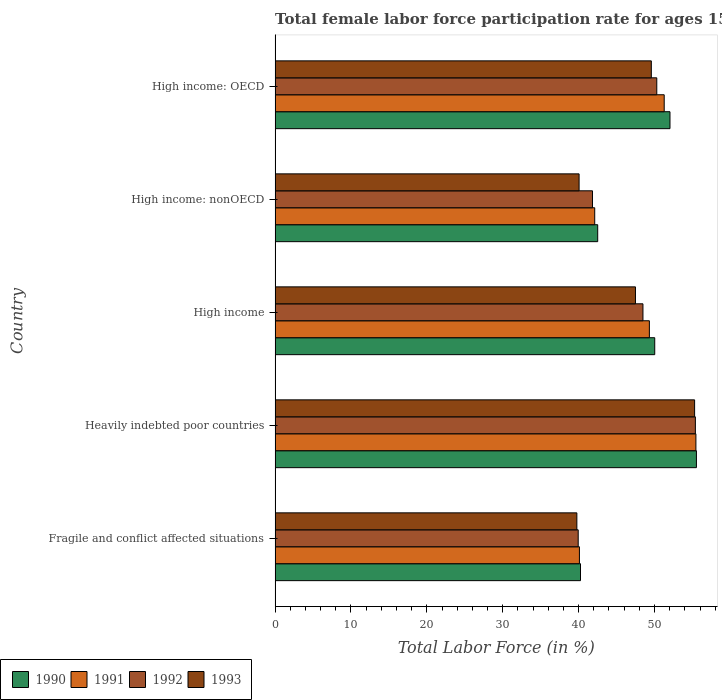How many different coloured bars are there?
Give a very brief answer. 4. Are the number of bars per tick equal to the number of legend labels?
Offer a terse response. Yes. How many bars are there on the 2nd tick from the top?
Your response must be concise. 4. What is the label of the 2nd group of bars from the top?
Provide a succinct answer. High income: nonOECD. What is the female labor force participation rate in 1991 in Fragile and conflict affected situations?
Your answer should be very brief. 40.11. Across all countries, what is the maximum female labor force participation rate in 1992?
Provide a succinct answer. 55.39. Across all countries, what is the minimum female labor force participation rate in 1993?
Provide a succinct answer. 39.77. In which country was the female labor force participation rate in 1993 maximum?
Provide a succinct answer. Heavily indebted poor countries. In which country was the female labor force participation rate in 1993 minimum?
Offer a very short reply. Fragile and conflict affected situations. What is the total female labor force participation rate in 1990 in the graph?
Make the answer very short. 240.38. What is the difference between the female labor force participation rate in 1991 in Heavily indebted poor countries and that in High income: OECD?
Your answer should be very brief. 4.18. What is the difference between the female labor force participation rate in 1990 in High income: OECD and the female labor force participation rate in 1993 in High income: nonOECD?
Your response must be concise. 11.98. What is the average female labor force participation rate in 1993 per country?
Make the answer very short. 46.44. What is the difference between the female labor force participation rate in 1990 and female labor force participation rate in 1993 in Fragile and conflict affected situations?
Your answer should be very brief. 0.48. In how many countries, is the female labor force participation rate in 1990 greater than 34 %?
Provide a succinct answer. 5. What is the ratio of the female labor force participation rate in 1993 in High income to that in High income: nonOECD?
Give a very brief answer. 1.19. Is the female labor force participation rate in 1993 in Heavily indebted poor countries less than that in High income: OECD?
Your response must be concise. No. Is the difference between the female labor force participation rate in 1990 in Heavily indebted poor countries and High income: OECD greater than the difference between the female labor force participation rate in 1993 in Heavily indebted poor countries and High income: OECD?
Your answer should be very brief. No. What is the difference between the highest and the second highest female labor force participation rate in 1992?
Your response must be concise. 5.09. What is the difference between the highest and the lowest female labor force participation rate in 1990?
Your answer should be compact. 15.28. What does the 2nd bar from the bottom in Fragile and conflict affected situations represents?
Ensure brevity in your answer.  1991. Are all the bars in the graph horizontal?
Ensure brevity in your answer.  Yes. What is the difference between two consecutive major ticks on the X-axis?
Make the answer very short. 10. Are the values on the major ticks of X-axis written in scientific E-notation?
Your response must be concise. No. Does the graph contain grids?
Keep it short and to the point. No. How many legend labels are there?
Keep it short and to the point. 4. What is the title of the graph?
Offer a terse response. Total female labor force participation rate for ages 15-24. What is the label or title of the X-axis?
Offer a very short reply. Total Labor Force (in %). What is the Total Labor Force (in %) in 1990 in Fragile and conflict affected situations?
Ensure brevity in your answer.  40.25. What is the Total Labor Force (in %) of 1991 in Fragile and conflict affected situations?
Offer a terse response. 40.11. What is the Total Labor Force (in %) in 1992 in Fragile and conflict affected situations?
Offer a terse response. 39.95. What is the Total Labor Force (in %) in 1993 in Fragile and conflict affected situations?
Make the answer very short. 39.77. What is the Total Labor Force (in %) in 1990 in Heavily indebted poor countries?
Provide a short and direct response. 55.53. What is the Total Labor Force (in %) of 1991 in Heavily indebted poor countries?
Give a very brief answer. 55.46. What is the Total Labor Force (in %) of 1992 in Heavily indebted poor countries?
Your response must be concise. 55.39. What is the Total Labor Force (in %) in 1993 in Heavily indebted poor countries?
Give a very brief answer. 55.29. What is the Total Labor Force (in %) in 1990 in High income?
Offer a terse response. 50.03. What is the Total Labor Force (in %) in 1991 in High income?
Provide a short and direct response. 49.33. What is the Total Labor Force (in %) in 1992 in High income?
Keep it short and to the point. 48.48. What is the Total Labor Force (in %) of 1993 in High income?
Your response must be concise. 47.5. What is the Total Labor Force (in %) of 1990 in High income: nonOECD?
Ensure brevity in your answer.  42.52. What is the Total Labor Force (in %) of 1991 in High income: nonOECD?
Provide a short and direct response. 42.12. What is the Total Labor Force (in %) of 1992 in High income: nonOECD?
Make the answer very short. 41.83. What is the Total Labor Force (in %) of 1993 in High income: nonOECD?
Give a very brief answer. 40.07. What is the Total Labor Force (in %) in 1990 in High income: OECD?
Your response must be concise. 52.04. What is the Total Labor Force (in %) in 1991 in High income: OECD?
Offer a terse response. 51.28. What is the Total Labor Force (in %) of 1992 in High income: OECD?
Your answer should be very brief. 50.3. What is the Total Labor Force (in %) in 1993 in High income: OECD?
Provide a succinct answer. 49.59. Across all countries, what is the maximum Total Labor Force (in %) in 1990?
Offer a terse response. 55.53. Across all countries, what is the maximum Total Labor Force (in %) in 1991?
Give a very brief answer. 55.46. Across all countries, what is the maximum Total Labor Force (in %) in 1992?
Keep it short and to the point. 55.39. Across all countries, what is the maximum Total Labor Force (in %) in 1993?
Give a very brief answer. 55.29. Across all countries, what is the minimum Total Labor Force (in %) of 1990?
Provide a succinct answer. 40.25. Across all countries, what is the minimum Total Labor Force (in %) in 1991?
Ensure brevity in your answer.  40.11. Across all countries, what is the minimum Total Labor Force (in %) in 1992?
Your answer should be compact. 39.95. Across all countries, what is the minimum Total Labor Force (in %) in 1993?
Provide a succinct answer. 39.77. What is the total Total Labor Force (in %) in 1990 in the graph?
Offer a terse response. 240.38. What is the total Total Labor Force (in %) of 1991 in the graph?
Provide a short and direct response. 238.31. What is the total Total Labor Force (in %) of 1992 in the graph?
Give a very brief answer. 235.96. What is the total Total Labor Force (in %) in 1993 in the graph?
Give a very brief answer. 232.21. What is the difference between the Total Labor Force (in %) of 1990 in Fragile and conflict affected situations and that in Heavily indebted poor countries?
Provide a succinct answer. -15.28. What is the difference between the Total Labor Force (in %) of 1991 in Fragile and conflict affected situations and that in Heavily indebted poor countries?
Provide a succinct answer. -15.35. What is the difference between the Total Labor Force (in %) of 1992 in Fragile and conflict affected situations and that in Heavily indebted poor countries?
Provide a succinct answer. -15.44. What is the difference between the Total Labor Force (in %) of 1993 in Fragile and conflict affected situations and that in Heavily indebted poor countries?
Your response must be concise. -15.52. What is the difference between the Total Labor Force (in %) in 1990 in Fragile and conflict affected situations and that in High income?
Provide a short and direct response. -9.78. What is the difference between the Total Labor Force (in %) of 1991 in Fragile and conflict affected situations and that in High income?
Ensure brevity in your answer.  -9.22. What is the difference between the Total Labor Force (in %) of 1992 in Fragile and conflict affected situations and that in High income?
Make the answer very short. -8.53. What is the difference between the Total Labor Force (in %) in 1993 in Fragile and conflict affected situations and that in High income?
Your answer should be very brief. -7.72. What is the difference between the Total Labor Force (in %) in 1990 in Fragile and conflict affected situations and that in High income: nonOECD?
Make the answer very short. -2.27. What is the difference between the Total Labor Force (in %) of 1991 in Fragile and conflict affected situations and that in High income: nonOECD?
Your answer should be very brief. -2.01. What is the difference between the Total Labor Force (in %) in 1992 in Fragile and conflict affected situations and that in High income: nonOECD?
Provide a succinct answer. -1.88. What is the difference between the Total Labor Force (in %) in 1993 in Fragile and conflict affected situations and that in High income: nonOECD?
Offer a terse response. -0.29. What is the difference between the Total Labor Force (in %) in 1990 in Fragile and conflict affected situations and that in High income: OECD?
Your answer should be very brief. -11.79. What is the difference between the Total Labor Force (in %) in 1991 in Fragile and conflict affected situations and that in High income: OECD?
Provide a succinct answer. -11.17. What is the difference between the Total Labor Force (in %) in 1992 in Fragile and conflict affected situations and that in High income: OECD?
Keep it short and to the point. -10.36. What is the difference between the Total Labor Force (in %) in 1993 in Fragile and conflict affected situations and that in High income: OECD?
Offer a very short reply. -9.81. What is the difference between the Total Labor Force (in %) of 1990 in Heavily indebted poor countries and that in High income?
Give a very brief answer. 5.5. What is the difference between the Total Labor Force (in %) in 1991 in Heavily indebted poor countries and that in High income?
Ensure brevity in your answer.  6.13. What is the difference between the Total Labor Force (in %) in 1992 in Heavily indebted poor countries and that in High income?
Your response must be concise. 6.91. What is the difference between the Total Labor Force (in %) of 1993 in Heavily indebted poor countries and that in High income?
Your response must be concise. 7.79. What is the difference between the Total Labor Force (in %) of 1990 in Heavily indebted poor countries and that in High income: nonOECD?
Ensure brevity in your answer.  13.01. What is the difference between the Total Labor Force (in %) in 1991 in Heavily indebted poor countries and that in High income: nonOECD?
Provide a succinct answer. 13.34. What is the difference between the Total Labor Force (in %) of 1992 in Heavily indebted poor countries and that in High income: nonOECD?
Give a very brief answer. 13.56. What is the difference between the Total Labor Force (in %) of 1993 in Heavily indebted poor countries and that in High income: nonOECD?
Provide a short and direct response. 15.22. What is the difference between the Total Labor Force (in %) of 1990 in Heavily indebted poor countries and that in High income: OECD?
Give a very brief answer. 3.49. What is the difference between the Total Labor Force (in %) in 1991 in Heavily indebted poor countries and that in High income: OECD?
Keep it short and to the point. 4.18. What is the difference between the Total Labor Force (in %) of 1992 in Heavily indebted poor countries and that in High income: OECD?
Keep it short and to the point. 5.09. What is the difference between the Total Labor Force (in %) in 1993 in Heavily indebted poor countries and that in High income: OECD?
Make the answer very short. 5.7. What is the difference between the Total Labor Force (in %) in 1990 in High income and that in High income: nonOECD?
Offer a terse response. 7.52. What is the difference between the Total Labor Force (in %) in 1991 in High income and that in High income: nonOECD?
Give a very brief answer. 7.2. What is the difference between the Total Labor Force (in %) of 1992 in High income and that in High income: nonOECD?
Give a very brief answer. 6.65. What is the difference between the Total Labor Force (in %) in 1993 in High income and that in High income: nonOECD?
Keep it short and to the point. 7.43. What is the difference between the Total Labor Force (in %) of 1990 in High income and that in High income: OECD?
Provide a short and direct response. -2.01. What is the difference between the Total Labor Force (in %) of 1991 in High income and that in High income: OECD?
Offer a terse response. -1.95. What is the difference between the Total Labor Force (in %) of 1992 in High income and that in High income: OECD?
Your answer should be very brief. -1.82. What is the difference between the Total Labor Force (in %) in 1993 in High income and that in High income: OECD?
Your response must be concise. -2.09. What is the difference between the Total Labor Force (in %) of 1990 in High income: nonOECD and that in High income: OECD?
Keep it short and to the point. -9.53. What is the difference between the Total Labor Force (in %) of 1991 in High income: nonOECD and that in High income: OECD?
Your answer should be compact. -9.16. What is the difference between the Total Labor Force (in %) of 1992 in High income: nonOECD and that in High income: OECD?
Provide a succinct answer. -8.47. What is the difference between the Total Labor Force (in %) in 1993 in High income: nonOECD and that in High income: OECD?
Provide a succinct answer. -9.52. What is the difference between the Total Labor Force (in %) of 1990 in Fragile and conflict affected situations and the Total Labor Force (in %) of 1991 in Heavily indebted poor countries?
Your answer should be compact. -15.21. What is the difference between the Total Labor Force (in %) in 1990 in Fragile and conflict affected situations and the Total Labor Force (in %) in 1992 in Heavily indebted poor countries?
Give a very brief answer. -15.14. What is the difference between the Total Labor Force (in %) in 1990 in Fragile and conflict affected situations and the Total Labor Force (in %) in 1993 in Heavily indebted poor countries?
Provide a short and direct response. -15.04. What is the difference between the Total Labor Force (in %) in 1991 in Fragile and conflict affected situations and the Total Labor Force (in %) in 1992 in Heavily indebted poor countries?
Give a very brief answer. -15.28. What is the difference between the Total Labor Force (in %) of 1991 in Fragile and conflict affected situations and the Total Labor Force (in %) of 1993 in Heavily indebted poor countries?
Provide a short and direct response. -15.18. What is the difference between the Total Labor Force (in %) in 1992 in Fragile and conflict affected situations and the Total Labor Force (in %) in 1993 in Heavily indebted poor countries?
Your answer should be compact. -15.34. What is the difference between the Total Labor Force (in %) in 1990 in Fragile and conflict affected situations and the Total Labor Force (in %) in 1991 in High income?
Your answer should be compact. -9.08. What is the difference between the Total Labor Force (in %) of 1990 in Fragile and conflict affected situations and the Total Labor Force (in %) of 1992 in High income?
Keep it short and to the point. -8.23. What is the difference between the Total Labor Force (in %) in 1990 in Fragile and conflict affected situations and the Total Labor Force (in %) in 1993 in High income?
Offer a terse response. -7.24. What is the difference between the Total Labor Force (in %) in 1991 in Fragile and conflict affected situations and the Total Labor Force (in %) in 1992 in High income?
Keep it short and to the point. -8.37. What is the difference between the Total Labor Force (in %) in 1991 in Fragile and conflict affected situations and the Total Labor Force (in %) in 1993 in High income?
Give a very brief answer. -7.38. What is the difference between the Total Labor Force (in %) of 1992 in Fragile and conflict affected situations and the Total Labor Force (in %) of 1993 in High income?
Your answer should be very brief. -7.55. What is the difference between the Total Labor Force (in %) of 1990 in Fragile and conflict affected situations and the Total Labor Force (in %) of 1991 in High income: nonOECD?
Give a very brief answer. -1.87. What is the difference between the Total Labor Force (in %) of 1990 in Fragile and conflict affected situations and the Total Labor Force (in %) of 1992 in High income: nonOECD?
Your answer should be compact. -1.58. What is the difference between the Total Labor Force (in %) in 1990 in Fragile and conflict affected situations and the Total Labor Force (in %) in 1993 in High income: nonOECD?
Your answer should be compact. 0.18. What is the difference between the Total Labor Force (in %) in 1991 in Fragile and conflict affected situations and the Total Labor Force (in %) in 1992 in High income: nonOECD?
Your response must be concise. -1.72. What is the difference between the Total Labor Force (in %) of 1991 in Fragile and conflict affected situations and the Total Labor Force (in %) of 1993 in High income: nonOECD?
Give a very brief answer. 0.04. What is the difference between the Total Labor Force (in %) in 1992 in Fragile and conflict affected situations and the Total Labor Force (in %) in 1993 in High income: nonOECD?
Your response must be concise. -0.12. What is the difference between the Total Labor Force (in %) of 1990 in Fragile and conflict affected situations and the Total Labor Force (in %) of 1991 in High income: OECD?
Provide a succinct answer. -11.03. What is the difference between the Total Labor Force (in %) in 1990 in Fragile and conflict affected situations and the Total Labor Force (in %) in 1992 in High income: OECD?
Your answer should be compact. -10.05. What is the difference between the Total Labor Force (in %) of 1990 in Fragile and conflict affected situations and the Total Labor Force (in %) of 1993 in High income: OECD?
Your answer should be very brief. -9.33. What is the difference between the Total Labor Force (in %) in 1991 in Fragile and conflict affected situations and the Total Labor Force (in %) in 1992 in High income: OECD?
Provide a short and direct response. -10.19. What is the difference between the Total Labor Force (in %) of 1991 in Fragile and conflict affected situations and the Total Labor Force (in %) of 1993 in High income: OECD?
Provide a short and direct response. -9.48. What is the difference between the Total Labor Force (in %) of 1992 in Fragile and conflict affected situations and the Total Labor Force (in %) of 1993 in High income: OECD?
Your response must be concise. -9.64. What is the difference between the Total Labor Force (in %) of 1990 in Heavily indebted poor countries and the Total Labor Force (in %) of 1991 in High income?
Your answer should be compact. 6.2. What is the difference between the Total Labor Force (in %) of 1990 in Heavily indebted poor countries and the Total Labor Force (in %) of 1992 in High income?
Provide a succinct answer. 7.05. What is the difference between the Total Labor Force (in %) in 1990 in Heavily indebted poor countries and the Total Labor Force (in %) in 1993 in High income?
Provide a succinct answer. 8.03. What is the difference between the Total Labor Force (in %) of 1991 in Heavily indebted poor countries and the Total Labor Force (in %) of 1992 in High income?
Give a very brief answer. 6.98. What is the difference between the Total Labor Force (in %) in 1991 in Heavily indebted poor countries and the Total Labor Force (in %) in 1993 in High income?
Offer a very short reply. 7.96. What is the difference between the Total Labor Force (in %) of 1992 in Heavily indebted poor countries and the Total Labor Force (in %) of 1993 in High income?
Your answer should be compact. 7.9. What is the difference between the Total Labor Force (in %) of 1990 in Heavily indebted poor countries and the Total Labor Force (in %) of 1991 in High income: nonOECD?
Your answer should be compact. 13.4. What is the difference between the Total Labor Force (in %) of 1990 in Heavily indebted poor countries and the Total Labor Force (in %) of 1992 in High income: nonOECD?
Make the answer very short. 13.7. What is the difference between the Total Labor Force (in %) of 1990 in Heavily indebted poor countries and the Total Labor Force (in %) of 1993 in High income: nonOECD?
Your response must be concise. 15.46. What is the difference between the Total Labor Force (in %) of 1991 in Heavily indebted poor countries and the Total Labor Force (in %) of 1992 in High income: nonOECD?
Ensure brevity in your answer.  13.63. What is the difference between the Total Labor Force (in %) of 1991 in Heavily indebted poor countries and the Total Labor Force (in %) of 1993 in High income: nonOECD?
Your answer should be very brief. 15.39. What is the difference between the Total Labor Force (in %) of 1992 in Heavily indebted poor countries and the Total Labor Force (in %) of 1993 in High income: nonOECD?
Provide a short and direct response. 15.33. What is the difference between the Total Labor Force (in %) in 1990 in Heavily indebted poor countries and the Total Labor Force (in %) in 1991 in High income: OECD?
Give a very brief answer. 4.25. What is the difference between the Total Labor Force (in %) of 1990 in Heavily indebted poor countries and the Total Labor Force (in %) of 1992 in High income: OECD?
Give a very brief answer. 5.23. What is the difference between the Total Labor Force (in %) of 1990 in Heavily indebted poor countries and the Total Labor Force (in %) of 1993 in High income: OECD?
Give a very brief answer. 5.94. What is the difference between the Total Labor Force (in %) in 1991 in Heavily indebted poor countries and the Total Labor Force (in %) in 1992 in High income: OECD?
Your answer should be very brief. 5.16. What is the difference between the Total Labor Force (in %) of 1991 in Heavily indebted poor countries and the Total Labor Force (in %) of 1993 in High income: OECD?
Offer a terse response. 5.87. What is the difference between the Total Labor Force (in %) in 1992 in Heavily indebted poor countries and the Total Labor Force (in %) in 1993 in High income: OECD?
Make the answer very short. 5.81. What is the difference between the Total Labor Force (in %) in 1990 in High income and the Total Labor Force (in %) in 1991 in High income: nonOECD?
Keep it short and to the point. 7.91. What is the difference between the Total Labor Force (in %) in 1990 in High income and the Total Labor Force (in %) in 1992 in High income: nonOECD?
Make the answer very short. 8.2. What is the difference between the Total Labor Force (in %) of 1990 in High income and the Total Labor Force (in %) of 1993 in High income: nonOECD?
Make the answer very short. 9.97. What is the difference between the Total Labor Force (in %) in 1991 in High income and the Total Labor Force (in %) in 1992 in High income: nonOECD?
Provide a short and direct response. 7.5. What is the difference between the Total Labor Force (in %) of 1991 in High income and the Total Labor Force (in %) of 1993 in High income: nonOECD?
Keep it short and to the point. 9.26. What is the difference between the Total Labor Force (in %) of 1992 in High income and the Total Labor Force (in %) of 1993 in High income: nonOECD?
Provide a short and direct response. 8.42. What is the difference between the Total Labor Force (in %) in 1990 in High income and the Total Labor Force (in %) in 1991 in High income: OECD?
Your answer should be very brief. -1.25. What is the difference between the Total Labor Force (in %) of 1990 in High income and the Total Labor Force (in %) of 1992 in High income: OECD?
Offer a terse response. -0.27. What is the difference between the Total Labor Force (in %) in 1990 in High income and the Total Labor Force (in %) in 1993 in High income: OECD?
Give a very brief answer. 0.45. What is the difference between the Total Labor Force (in %) of 1991 in High income and the Total Labor Force (in %) of 1992 in High income: OECD?
Provide a succinct answer. -0.98. What is the difference between the Total Labor Force (in %) of 1991 in High income and the Total Labor Force (in %) of 1993 in High income: OECD?
Your answer should be very brief. -0.26. What is the difference between the Total Labor Force (in %) of 1992 in High income and the Total Labor Force (in %) of 1993 in High income: OECD?
Your response must be concise. -1.1. What is the difference between the Total Labor Force (in %) in 1990 in High income: nonOECD and the Total Labor Force (in %) in 1991 in High income: OECD?
Make the answer very short. -8.76. What is the difference between the Total Labor Force (in %) in 1990 in High income: nonOECD and the Total Labor Force (in %) in 1992 in High income: OECD?
Ensure brevity in your answer.  -7.79. What is the difference between the Total Labor Force (in %) in 1990 in High income: nonOECD and the Total Labor Force (in %) in 1993 in High income: OECD?
Offer a very short reply. -7.07. What is the difference between the Total Labor Force (in %) in 1991 in High income: nonOECD and the Total Labor Force (in %) in 1992 in High income: OECD?
Offer a very short reply. -8.18. What is the difference between the Total Labor Force (in %) in 1991 in High income: nonOECD and the Total Labor Force (in %) in 1993 in High income: OECD?
Provide a short and direct response. -7.46. What is the difference between the Total Labor Force (in %) of 1992 in High income: nonOECD and the Total Labor Force (in %) of 1993 in High income: OECD?
Your answer should be compact. -7.75. What is the average Total Labor Force (in %) of 1990 per country?
Your response must be concise. 48.08. What is the average Total Labor Force (in %) in 1991 per country?
Ensure brevity in your answer.  47.66. What is the average Total Labor Force (in %) of 1992 per country?
Offer a very short reply. 47.19. What is the average Total Labor Force (in %) of 1993 per country?
Give a very brief answer. 46.44. What is the difference between the Total Labor Force (in %) of 1990 and Total Labor Force (in %) of 1991 in Fragile and conflict affected situations?
Give a very brief answer. 0.14. What is the difference between the Total Labor Force (in %) of 1990 and Total Labor Force (in %) of 1992 in Fragile and conflict affected situations?
Offer a terse response. 0.3. What is the difference between the Total Labor Force (in %) of 1990 and Total Labor Force (in %) of 1993 in Fragile and conflict affected situations?
Offer a terse response. 0.48. What is the difference between the Total Labor Force (in %) in 1991 and Total Labor Force (in %) in 1992 in Fragile and conflict affected situations?
Offer a terse response. 0.16. What is the difference between the Total Labor Force (in %) in 1991 and Total Labor Force (in %) in 1993 in Fragile and conflict affected situations?
Provide a succinct answer. 0.34. What is the difference between the Total Labor Force (in %) of 1992 and Total Labor Force (in %) of 1993 in Fragile and conflict affected situations?
Offer a very short reply. 0.18. What is the difference between the Total Labor Force (in %) of 1990 and Total Labor Force (in %) of 1991 in Heavily indebted poor countries?
Give a very brief answer. 0.07. What is the difference between the Total Labor Force (in %) of 1990 and Total Labor Force (in %) of 1992 in Heavily indebted poor countries?
Ensure brevity in your answer.  0.14. What is the difference between the Total Labor Force (in %) of 1990 and Total Labor Force (in %) of 1993 in Heavily indebted poor countries?
Your answer should be very brief. 0.24. What is the difference between the Total Labor Force (in %) in 1991 and Total Labor Force (in %) in 1992 in Heavily indebted poor countries?
Your answer should be very brief. 0.07. What is the difference between the Total Labor Force (in %) of 1991 and Total Labor Force (in %) of 1993 in Heavily indebted poor countries?
Provide a short and direct response. 0.17. What is the difference between the Total Labor Force (in %) in 1992 and Total Labor Force (in %) in 1993 in Heavily indebted poor countries?
Provide a succinct answer. 0.1. What is the difference between the Total Labor Force (in %) of 1990 and Total Labor Force (in %) of 1991 in High income?
Your answer should be compact. 0.71. What is the difference between the Total Labor Force (in %) of 1990 and Total Labor Force (in %) of 1992 in High income?
Ensure brevity in your answer.  1.55. What is the difference between the Total Labor Force (in %) in 1990 and Total Labor Force (in %) in 1993 in High income?
Your answer should be compact. 2.54. What is the difference between the Total Labor Force (in %) in 1991 and Total Labor Force (in %) in 1992 in High income?
Give a very brief answer. 0.85. What is the difference between the Total Labor Force (in %) of 1991 and Total Labor Force (in %) of 1993 in High income?
Your answer should be very brief. 1.83. What is the difference between the Total Labor Force (in %) in 1992 and Total Labor Force (in %) in 1993 in High income?
Offer a terse response. 0.99. What is the difference between the Total Labor Force (in %) in 1990 and Total Labor Force (in %) in 1991 in High income: nonOECD?
Offer a terse response. 0.39. What is the difference between the Total Labor Force (in %) in 1990 and Total Labor Force (in %) in 1992 in High income: nonOECD?
Offer a terse response. 0.69. What is the difference between the Total Labor Force (in %) of 1990 and Total Labor Force (in %) of 1993 in High income: nonOECD?
Provide a succinct answer. 2.45. What is the difference between the Total Labor Force (in %) of 1991 and Total Labor Force (in %) of 1992 in High income: nonOECD?
Your response must be concise. 0.29. What is the difference between the Total Labor Force (in %) of 1991 and Total Labor Force (in %) of 1993 in High income: nonOECD?
Give a very brief answer. 2.06. What is the difference between the Total Labor Force (in %) of 1992 and Total Labor Force (in %) of 1993 in High income: nonOECD?
Your response must be concise. 1.77. What is the difference between the Total Labor Force (in %) in 1990 and Total Labor Force (in %) in 1991 in High income: OECD?
Your response must be concise. 0.76. What is the difference between the Total Labor Force (in %) in 1990 and Total Labor Force (in %) in 1992 in High income: OECD?
Your response must be concise. 1.74. What is the difference between the Total Labor Force (in %) of 1990 and Total Labor Force (in %) of 1993 in High income: OECD?
Provide a succinct answer. 2.46. What is the difference between the Total Labor Force (in %) in 1991 and Total Labor Force (in %) in 1992 in High income: OECD?
Make the answer very short. 0.98. What is the difference between the Total Labor Force (in %) of 1991 and Total Labor Force (in %) of 1993 in High income: OECD?
Ensure brevity in your answer.  1.7. What is the difference between the Total Labor Force (in %) of 1992 and Total Labor Force (in %) of 1993 in High income: OECD?
Keep it short and to the point. 0.72. What is the ratio of the Total Labor Force (in %) in 1990 in Fragile and conflict affected situations to that in Heavily indebted poor countries?
Provide a succinct answer. 0.72. What is the ratio of the Total Labor Force (in %) of 1991 in Fragile and conflict affected situations to that in Heavily indebted poor countries?
Ensure brevity in your answer.  0.72. What is the ratio of the Total Labor Force (in %) of 1992 in Fragile and conflict affected situations to that in Heavily indebted poor countries?
Provide a succinct answer. 0.72. What is the ratio of the Total Labor Force (in %) in 1993 in Fragile and conflict affected situations to that in Heavily indebted poor countries?
Your answer should be compact. 0.72. What is the ratio of the Total Labor Force (in %) in 1990 in Fragile and conflict affected situations to that in High income?
Your response must be concise. 0.8. What is the ratio of the Total Labor Force (in %) of 1991 in Fragile and conflict affected situations to that in High income?
Offer a very short reply. 0.81. What is the ratio of the Total Labor Force (in %) in 1992 in Fragile and conflict affected situations to that in High income?
Keep it short and to the point. 0.82. What is the ratio of the Total Labor Force (in %) of 1993 in Fragile and conflict affected situations to that in High income?
Provide a succinct answer. 0.84. What is the ratio of the Total Labor Force (in %) in 1990 in Fragile and conflict affected situations to that in High income: nonOECD?
Give a very brief answer. 0.95. What is the ratio of the Total Labor Force (in %) in 1991 in Fragile and conflict affected situations to that in High income: nonOECD?
Offer a very short reply. 0.95. What is the ratio of the Total Labor Force (in %) of 1992 in Fragile and conflict affected situations to that in High income: nonOECD?
Provide a succinct answer. 0.95. What is the ratio of the Total Labor Force (in %) of 1990 in Fragile and conflict affected situations to that in High income: OECD?
Offer a terse response. 0.77. What is the ratio of the Total Labor Force (in %) in 1991 in Fragile and conflict affected situations to that in High income: OECD?
Offer a very short reply. 0.78. What is the ratio of the Total Labor Force (in %) of 1992 in Fragile and conflict affected situations to that in High income: OECD?
Ensure brevity in your answer.  0.79. What is the ratio of the Total Labor Force (in %) in 1993 in Fragile and conflict affected situations to that in High income: OECD?
Give a very brief answer. 0.8. What is the ratio of the Total Labor Force (in %) of 1990 in Heavily indebted poor countries to that in High income?
Your answer should be compact. 1.11. What is the ratio of the Total Labor Force (in %) in 1991 in Heavily indebted poor countries to that in High income?
Ensure brevity in your answer.  1.12. What is the ratio of the Total Labor Force (in %) of 1992 in Heavily indebted poor countries to that in High income?
Give a very brief answer. 1.14. What is the ratio of the Total Labor Force (in %) of 1993 in Heavily indebted poor countries to that in High income?
Make the answer very short. 1.16. What is the ratio of the Total Labor Force (in %) in 1990 in Heavily indebted poor countries to that in High income: nonOECD?
Your response must be concise. 1.31. What is the ratio of the Total Labor Force (in %) in 1991 in Heavily indebted poor countries to that in High income: nonOECD?
Your response must be concise. 1.32. What is the ratio of the Total Labor Force (in %) in 1992 in Heavily indebted poor countries to that in High income: nonOECD?
Your response must be concise. 1.32. What is the ratio of the Total Labor Force (in %) in 1993 in Heavily indebted poor countries to that in High income: nonOECD?
Ensure brevity in your answer.  1.38. What is the ratio of the Total Labor Force (in %) in 1990 in Heavily indebted poor countries to that in High income: OECD?
Provide a succinct answer. 1.07. What is the ratio of the Total Labor Force (in %) of 1991 in Heavily indebted poor countries to that in High income: OECD?
Offer a terse response. 1.08. What is the ratio of the Total Labor Force (in %) in 1992 in Heavily indebted poor countries to that in High income: OECD?
Give a very brief answer. 1.1. What is the ratio of the Total Labor Force (in %) of 1993 in Heavily indebted poor countries to that in High income: OECD?
Provide a short and direct response. 1.11. What is the ratio of the Total Labor Force (in %) of 1990 in High income to that in High income: nonOECD?
Your answer should be compact. 1.18. What is the ratio of the Total Labor Force (in %) of 1991 in High income to that in High income: nonOECD?
Give a very brief answer. 1.17. What is the ratio of the Total Labor Force (in %) of 1992 in High income to that in High income: nonOECD?
Your answer should be very brief. 1.16. What is the ratio of the Total Labor Force (in %) of 1993 in High income to that in High income: nonOECD?
Offer a terse response. 1.19. What is the ratio of the Total Labor Force (in %) in 1990 in High income to that in High income: OECD?
Provide a succinct answer. 0.96. What is the ratio of the Total Labor Force (in %) of 1991 in High income to that in High income: OECD?
Your answer should be very brief. 0.96. What is the ratio of the Total Labor Force (in %) of 1992 in High income to that in High income: OECD?
Keep it short and to the point. 0.96. What is the ratio of the Total Labor Force (in %) of 1993 in High income to that in High income: OECD?
Your response must be concise. 0.96. What is the ratio of the Total Labor Force (in %) in 1990 in High income: nonOECD to that in High income: OECD?
Your answer should be compact. 0.82. What is the ratio of the Total Labor Force (in %) of 1991 in High income: nonOECD to that in High income: OECD?
Keep it short and to the point. 0.82. What is the ratio of the Total Labor Force (in %) of 1992 in High income: nonOECD to that in High income: OECD?
Offer a very short reply. 0.83. What is the ratio of the Total Labor Force (in %) in 1993 in High income: nonOECD to that in High income: OECD?
Provide a succinct answer. 0.81. What is the difference between the highest and the second highest Total Labor Force (in %) of 1990?
Ensure brevity in your answer.  3.49. What is the difference between the highest and the second highest Total Labor Force (in %) of 1991?
Offer a terse response. 4.18. What is the difference between the highest and the second highest Total Labor Force (in %) in 1992?
Provide a succinct answer. 5.09. What is the difference between the highest and the second highest Total Labor Force (in %) in 1993?
Provide a succinct answer. 5.7. What is the difference between the highest and the lowest Total Labor Force (in %) in 1990?
Provide a succinct answer. 15.28. What is the difference between the highest and the lowest Total Labor Force (in %) in 1991?
Offer a very short reply. 15.35. What is the difference between the highest and the lowest Total Labor Force (in %) in 1992?
Provide a short and direct response. 15.44. What is the difference between the highest and the lowest Total Labor Force (in %) of 1993?
Offer a very short reply. 15.52. 